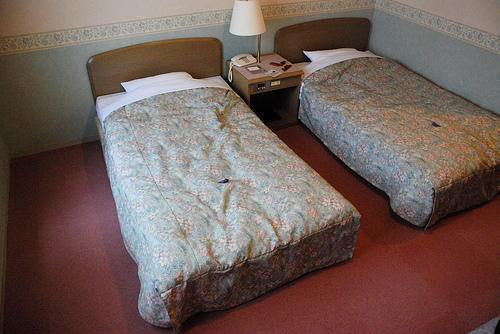How many beds are there?
Give a very brief answer. 2. How many lamps are there?
Give a very brief answer. 1. 